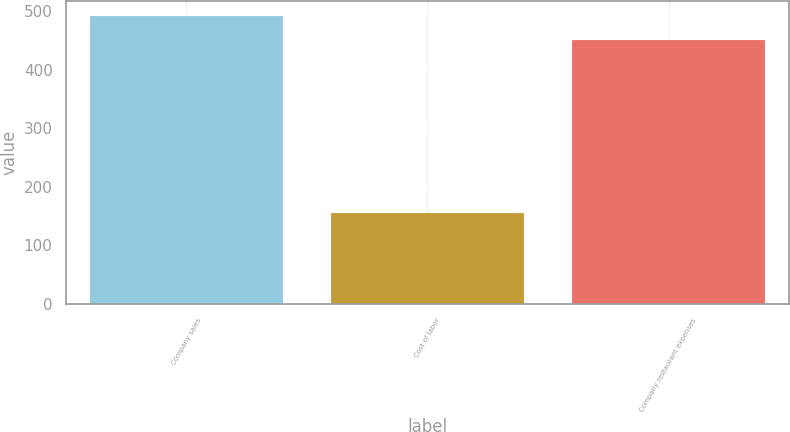Convert chart to OTSL. <chart><loc_0><loc_0><loc_500><loc_500><bar_chart><fcel>Company sales<fcel>Cost of labor<fcel>Company restaurant expenses<nl><fcel>493<fcel>156<fcel>452<nl></chart> 